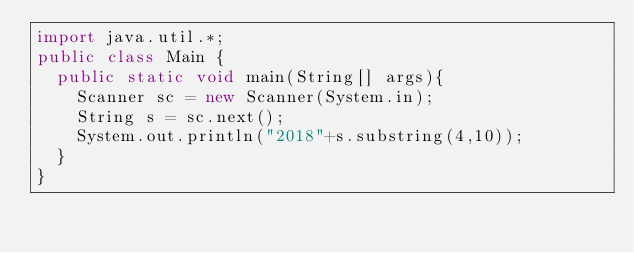Convert code to text. <code><loc_0><loc_0><loc_500><loc_500><_Java_>import java.util.*;
public class Main {
  public static void main(String[] args){
    Scanner sc = new Scanner(System.in);
    String s = sc.next();
    System.out.println("2018"+s.substring(4,10));
  }
}
</code> 